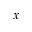<formula> <loc_0><loc_0><loc_500><loc_500>x</formula> 